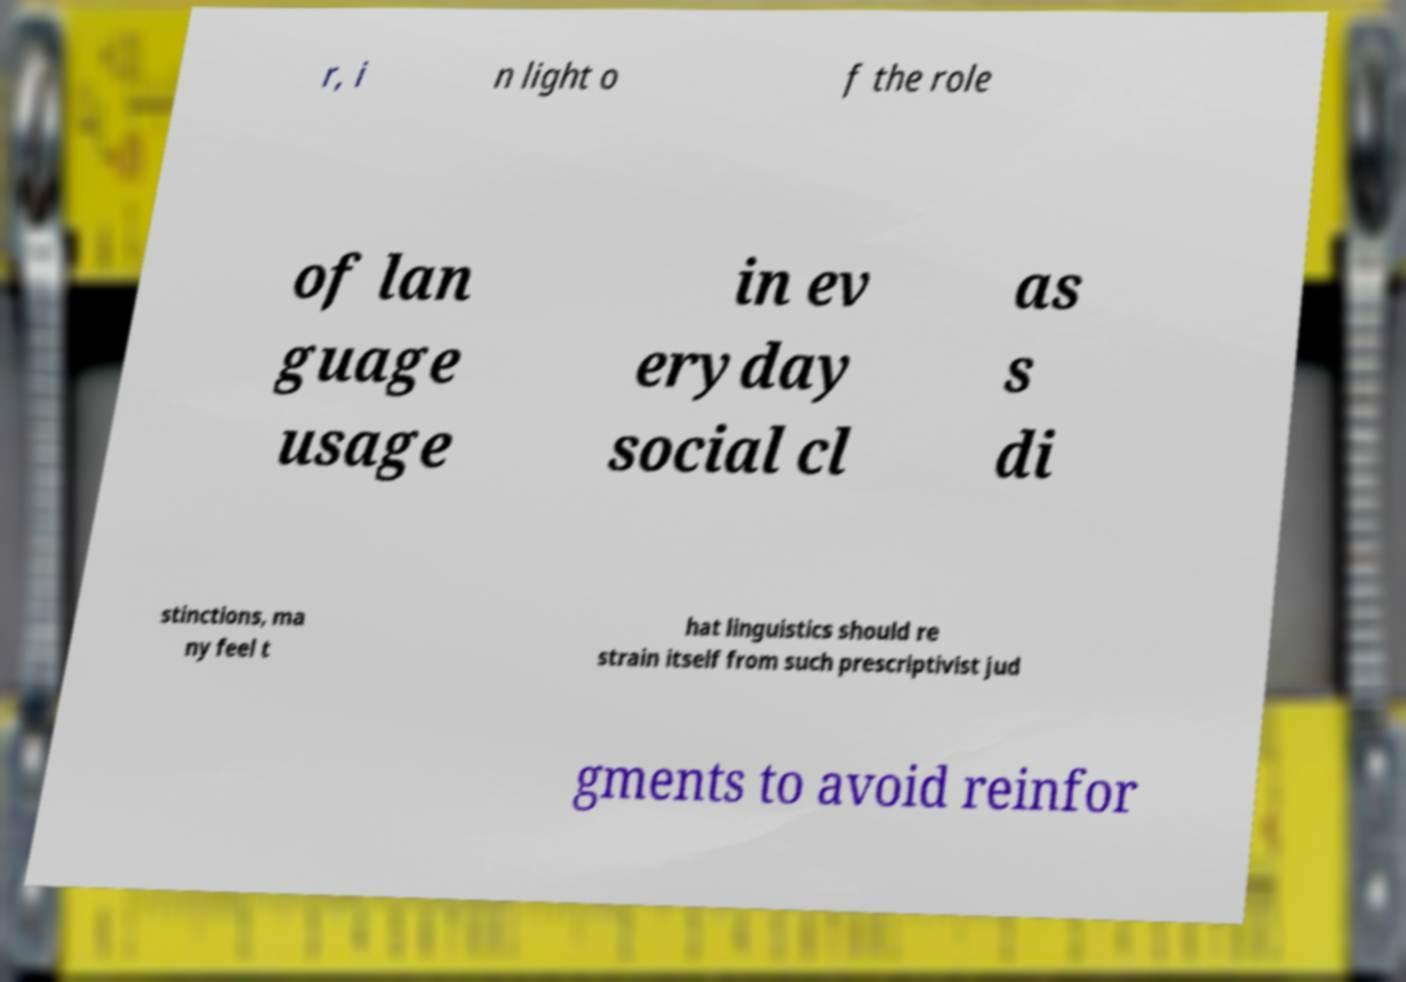I need the written content from this picture converted into text. Can you do that? r, i n light o f the role of lan guage usage in ev eryday social cl as s di stinctions, ma ny feel t hat linguistics should re strain itself from such prescriptivist jud gments to avoid reinfor 